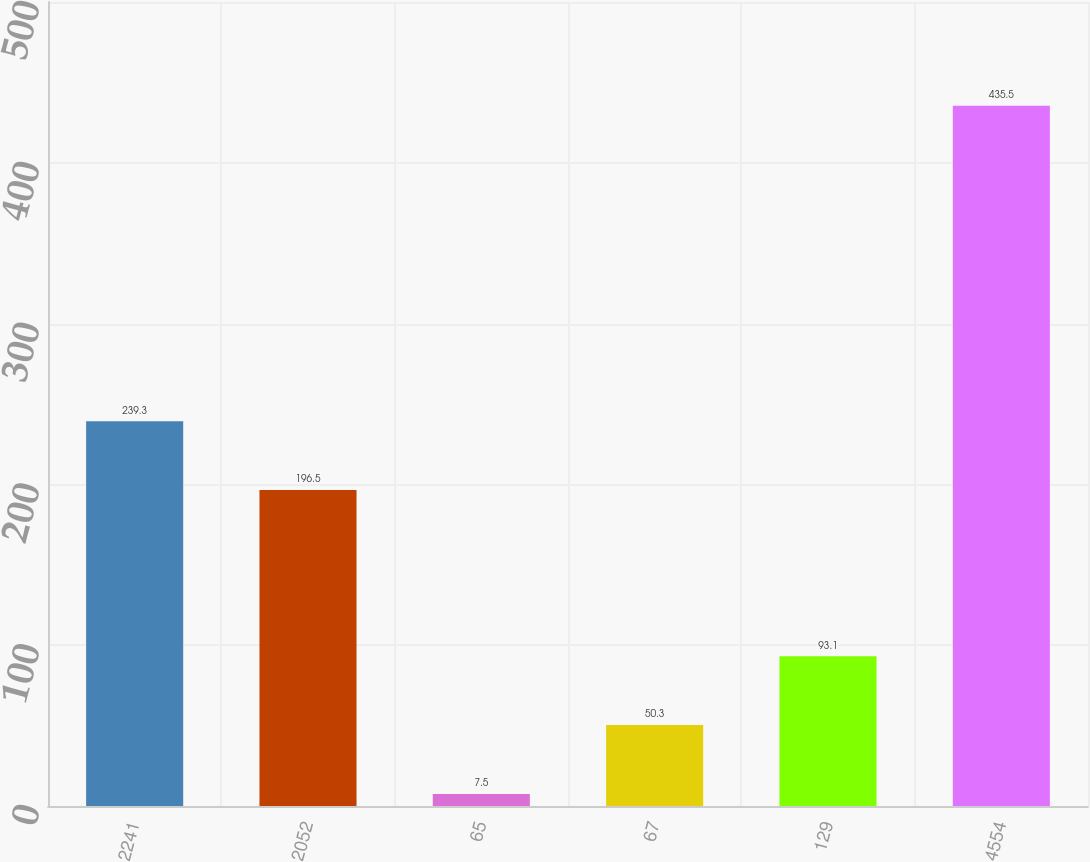<chart> <loc_0><loc_0><loc_500><loc_500><bar_chart><fcel>2241<fcel>2052<fcel>65<fcel>67<fcel>129<fcel>4554<nl><fcel>239.3<fcel>196.5<fcel>7.5<fcel>50.3<fcel>93.1<fcel>435.5<nl></chart> 